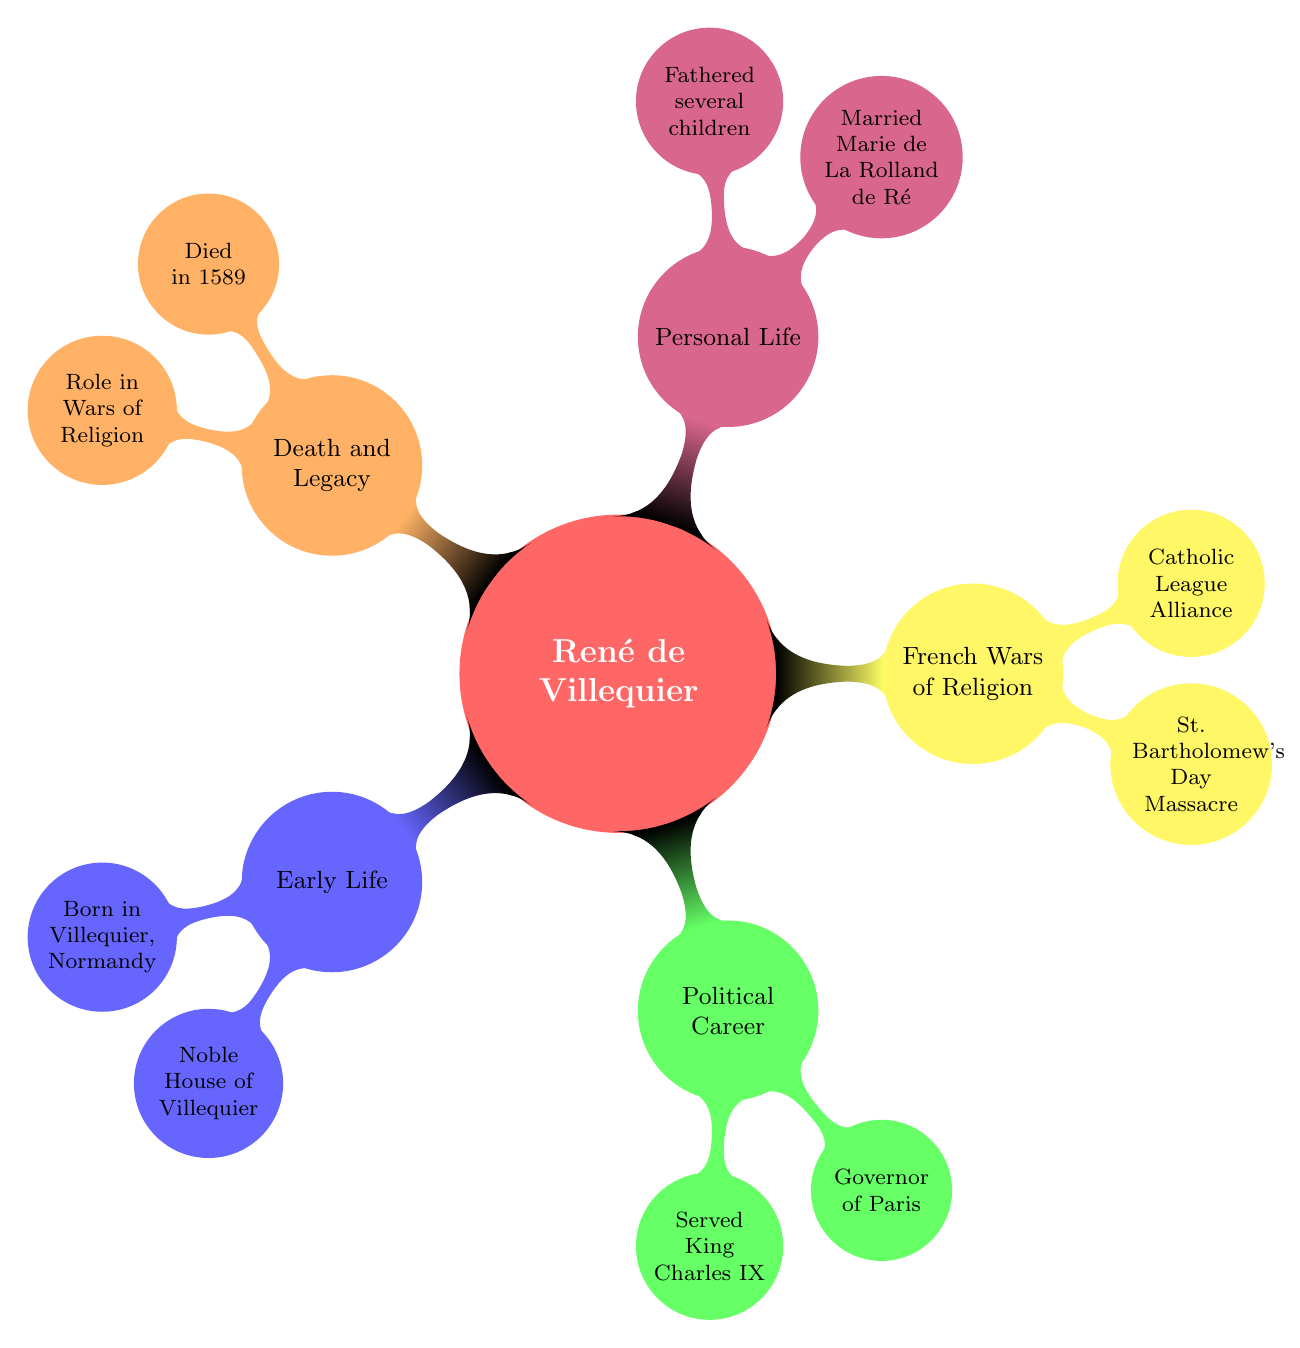What is René de Villequier’s place of birth? The node under "Early Life" specifies his birth, stating he was "Born in Villequier, Normandy." Therefore, the answer directly comes from this node.
Answer: Villequier, Normandy Who did René de Villequier serve in his political career? The node under "Political Career" indicates that he "Served King Charles IX of France." The answer is present in this section.
Answer: King Charles IX of France What title was René de Villequier appointed to during his service? According to the "Political Career" section, he was "Appointed Governor of Paris." This key event is noted in the mind map.
Answer: Governor of Paris In which significant event during the French Wars of Religion was René de Villequier an active participant? The node under "French Wars of Religion" notes that he was an "Active participant in planning" the "St. Bartholomew's Day Massacre," linking these elements.
Answer: St. Bartholomew's Day Massacre What legacy did René de Villequier leave behind in relation to his family? The "Personal Life" section states he "Fathered several children who continued the lineage." This indicates his importance to the continuation of his family line.
Answer: Several children who continued the lineage What year did René de Villequier die? The "Death and Legacy" section contains the information that he "Died in 1589," providing a specific detail of his life.
Answer: 1589 How did René de Villequier align himself during the French Wars of Religion? The "French Wars of Religion" component mentions his "Alliance with the Catholic League." This summarizes his political alignment during this turbulent time.
Answer: Catholic League What familial relationship did René de Villequier have with Marie de La Rolland de Ré? Under "Personal Life," it states he "Married Marie de La Rolland de Ré," making the nature of their relationship clear.
Answer: Married Which historical context is René de Villequier associated with due to his actions? The "Death and Legacy" section points out his "Role in the Wars of Religion," indicating his significant position in this historical context.
Answer: Role in Wars of Religion 